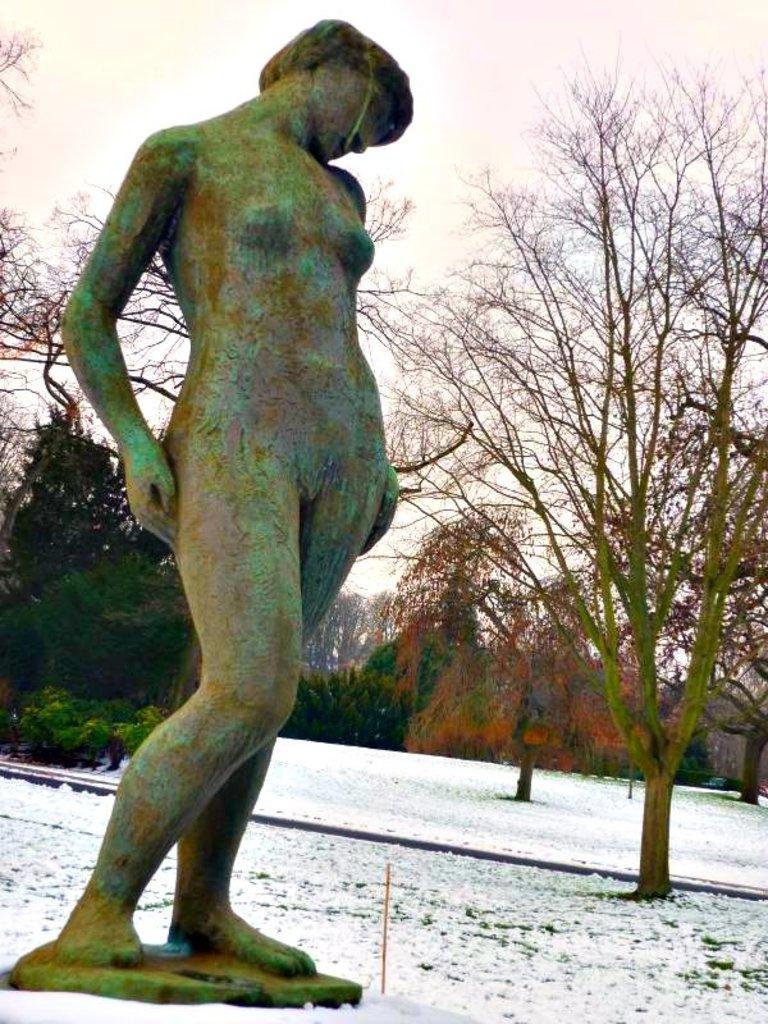Can you describe this image briefly? In this picture there is a statue on the left side of the image and there is snow at the bottom side of the image and there are trees in the background area of the image. 